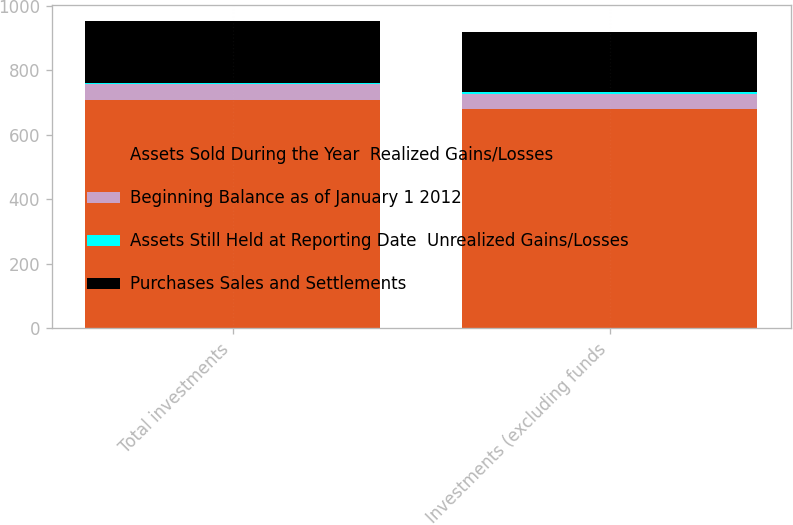<chart> <loc_0><loc_0><loc_500><loc_500><stacked_bar_chart><ecel><fcel>Total investments<fcel>Investments (excluding funds<nl><fcel>Assets Sold During the Year  Realized Gains/Losses<fcel>708<fcel>680<nl><fcel>Beginning Balance as of January 1 2012<fcel>49<fcel>47<nl><fcel>Assets Still Held at Reporting Date  Unrealized Gains/Losses<fcel>5<fcel>5<nl><fcel>Purchases Sales and Settlements<fcel>192<fcel>188<nl></chart> 